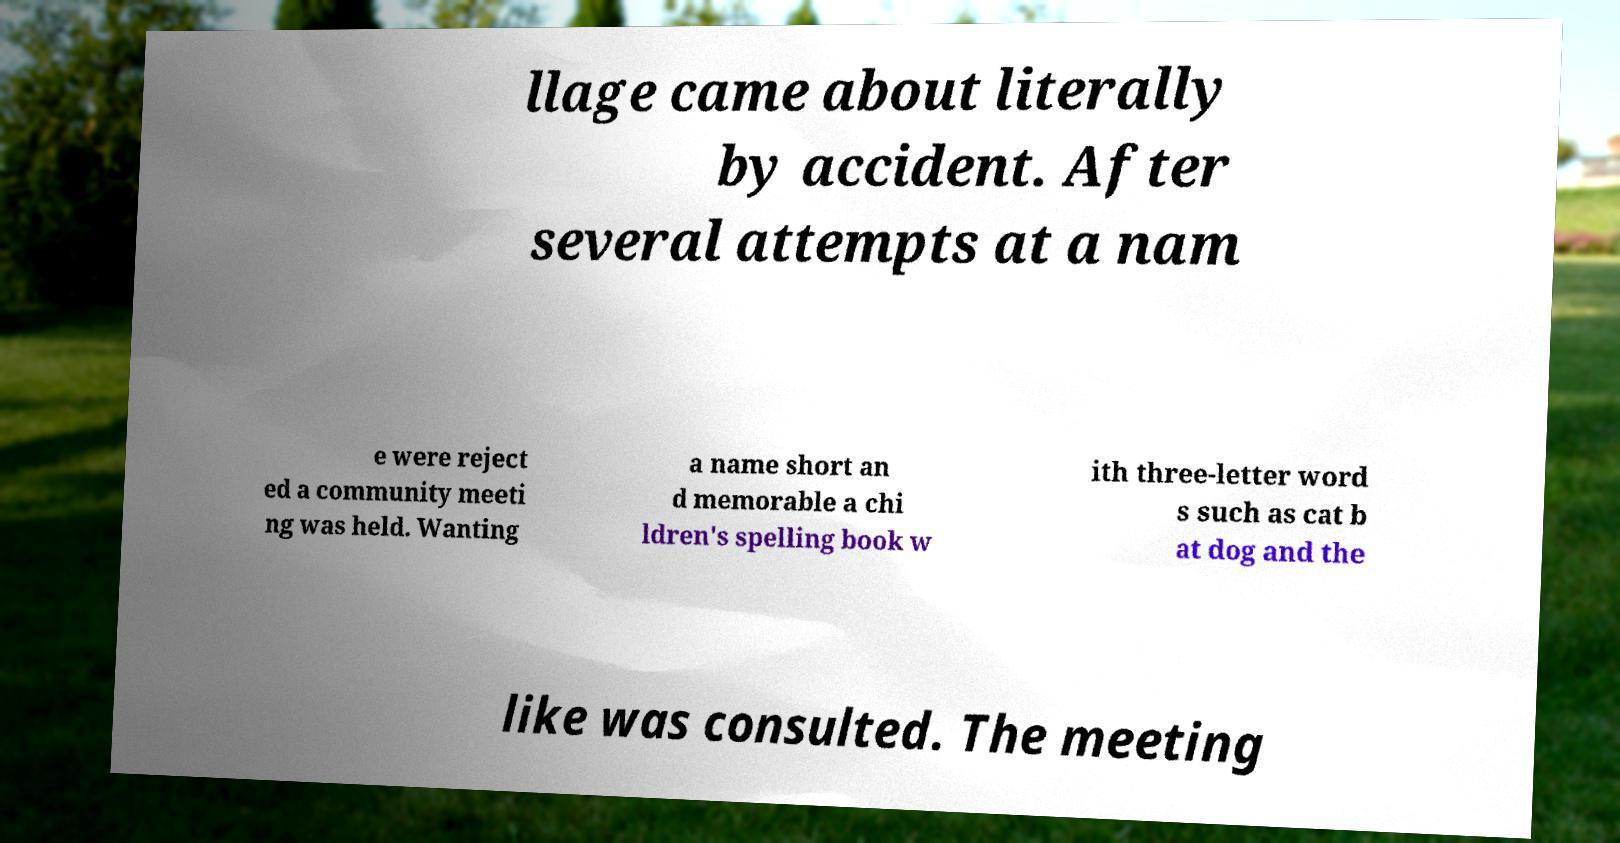For documentation purposes, I need the text within this image transcribed. Could you provide that? llage came about literally by accident. After several attempts at a nam e were reject ed a community meeti ng was held. Wanting a name short an d memorable a chi ldren's spelling book w ith three-letter word s such as cat b at dog and the like was consulted. The meeting 